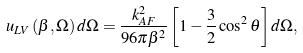<formula> <loc_0><loc_0><loc_500><loc_500>u _ { L V } \left ( \beta , \Omega \right ) d \Omega = \frac { k _ { A F } ^ { 2 } } { 9 6 \pi \beta ^ { 2 } } \left [ 1 - \frac { 3 } { 2 } \cos ^ { 2 } \theta \right ] d \Omega ,</formula> 